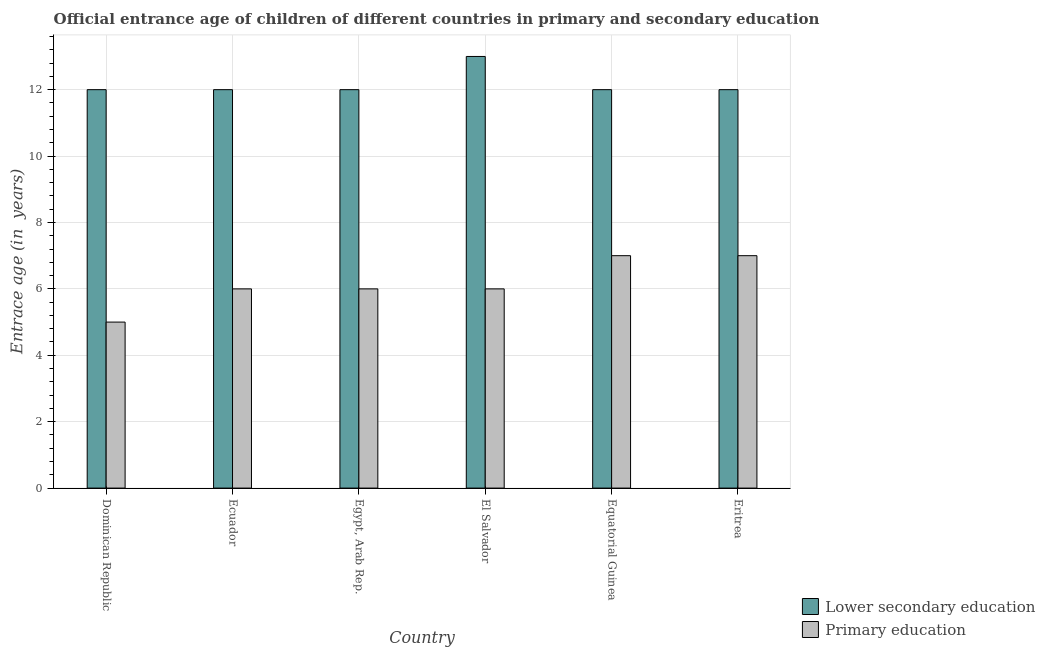Are the number of bars on each tick of the X-axis equal?
Your answer should be compact. Yes. How many bars are there on the 6th tick from the right?
Provide a short and direct response. 2. What is the label of the 4th group of bars from the left?
Offer a very short reply. El Salvador. What is the entrance age of chiildren in primary education in Egypt, Arab Rep.?
Your answer should be very brief. 6. Across all countries, what is the maximum entrance age of chiildren in primary education?
Provide a short and direct response. 7. Across all countries, what is the minimum entrance age of children in lower secondary education?
Your answer should be compact. 12. In which country was the entrance age of chiildren in primary education maximum?
Your answer should be very brief. Equatorial Guinea. In which country was the entrance age of chiildren in primary education minimum?
Make the answer very short. Dominican Republic. What is the total entrance age of children in lower secondary education in the graph?
Your response must be concise. 73. What is the difference between the entrance age of chiildren in primary education in Dominican Republic and the entrance age of children in lower secondary education in Eritrea?
Keep it short and to the point. -7. What is the average entrance age of chiildren in primary education per country?
Keep it short and to the point. 6.17. What is the difference between the entrance age of chiildren in primary education and entrance age of children in lower secondary education in El Salvador?
Keep it short and to the point. -7. What is the ratio of the entrance age of chiildren in primary education in Dominican Republic to that in El Salvador?
Give a very brief answer. 0.83. What is the difference between the highest and the lowest entrance age of children in lower secondary education?
Keep it short and to the point. 1. What does the 2nd bar from the left in Ecuador represents?
Make the answer very short. Primary education. What does the 2nd bar from the right in Dominican Republic represents?
Your answer should be very brief. Lower secondary education. How many bars are there?
Provide a short and direct response. 12. Are all the bars in the graph horizontal?
Offer a terse response. No. What is the difference between two consecutive major ticks on the Y-axis?
Your answer should be compact. 2. Are the values on the major ticks of Y-axis written in scientific E-notation?
Offer a very short reply. No. Where does the legend appear in the graph?
Make the answer very short. Bottom right. How many legend labels are there?
Provide a succinct answer. 2. How are the legend labels stacked?
Give a very brief answer. Vertical. What is the title of the graph?
Give a very brief answer. Official entrance age of children of different countries in primary and secondary education. Does "Gasoline" appear as one of the legend labels in the graph?
Make the answer very short. No. What is the label or title of the Y-axis?
Your answer should be compact. Entrace age (in  years). What is the Entrace age (in  years) in Primary education in Dominican Republic?
Offer a terse response. 5. What is the Entrace age (in  years) of Primary education in Ecuador?
Make the answer very short. 6. What is the Entrace age (in  years) in Lower secondary education in Egypt, Arab Rep.?
Keep it short and to the point. 12. What is the Entrace age (in  years) in Primary education in Egypt, Arab Rep.?
Offer a very short reply. 6. What is the Entrace age (in  years) in Lower secondary education in El Salvador?
Your answer should be very brief. 13. What is the Entrace age (in  years) of Primary education in El Salvador?
Make the answer very short. 6. Across all countries, what is the maximum Entrace age (in  years) in Lower secondary education?
Your answer should be very brief. 13. Across all countries, what is the maximum Entrace age (in  years) in Primary education?
Your answer should be compact. 7. Across all countries, what is the minimum Entrace age (in  years) of Primary education?
Keep it short and to the point. 5. What is the total Entrace age (in  years) in Lower secondary education in the graph?
Keep it short and to the point. 73. What is the difference between the Entrace age (in  years) of Lower secondary education in Dominican Republic and that in Ecuador?
Offer a very short reply. 0. What is the difference between the Entrace age (in  years) in Lower secondary education in Dominican Republic and that in Egypt, Arab Rep.?
Offer a terse response. 0. What is the difference between the Entrace age (in  years) in Lower secondary education in Dominican Republic and that in El Salvador?
Provide a succinct answer. -1. What is the difference between the Entrace age (in  years) in Lower secondary education in Dominican Republic and that in Eritrea?
Offer a very short reply. 0. What is the difference between the Entrace age (in  years) in Primary education in Dominican Republic and that in Eritrea?
Your response must be concise. -2. What is the difference between the Entrace age (in  years) of Lower secondary education in Ecuador and that in Egypt, Arab Rep.?
Offer a terse response. 0. What is the difference between the Entrace age (in  years) of Primary education in Ecuador and that in Egypt, Arab Rep.?
Make the answer very short. 0. What is the difference between the Entrace age (in  years) in Lower secondary education in Ecuador and that in El Salvador?
Provide a succinct answer. -1. What is the difference between the Entrace age (in  years) in Primary education in Ecuador and that in El Salvador?
Your answer should be very brief. 0. What is the difference between the Entrace age (in  years) in Lower secondary education in Ecuador and that in Equatorial Guinea?
Offer a terse response. 0. What is the difference between the Entrace age (in  years) in Primary education in Ecuador and that in Equatorial Guinea?
Your response must be concise. -1. What is the difference between the Entrace age (in  years) of Primary education in Egypt, Arab Rep. and that in El Salvador?
Give a very brief answer. 0. What is the difference between the Entrace age (in  years) in Lower secondary education in Egypt, Arab Rep. and that in Equatorial Guinea?
Your answer should be very brief. 0. What is the difference between the Entrace age (in  years) in Primary education in Egypt, Arab Rep. and that in Equatorial Guinea?
Make the answer very short. -1. What is the difference between the Entrace age (in  years) in Primary education in Egypt, Arab Rep. and that in Eritrea?
Your answer should be compact. -1. What is the difference between the Entrace age (in  years) of Lower secondary education in El Salvador and that in Eritrea?
Keep it short and to the point. 1. What is the difference between the Entrace age (in  years) of Primary education in El Salvador and that in Eritrea?
Make the answer very short. -1. What is the difference between the Entrace age (in  years) of Lower secondary education in Dominican Republic and the Entrace age (in  years) of Primary education in Egypt, Arab Rep.?
Provide a short and direct response. 6. What is the difference between the Entrace age (in  years) in Lower secondary education in Dominican Republic and the Entrace age (in  years) in Primary education in El Salvador?
Your answer should be very brief. 6. What is the difference between the Entrace age (in  years) of Lower secondary education in Dominican Republic and the Entrace age (in  years) of Primary education in Equatorial Guinea?
Ensure brevity in your answer.  5. What is the difference between the Entrace age (in  years) of Lower secondary education in Ecuador and the Entrace age (in  years) of Primary education in Egypt, Arab Rep.?
Your response must be concise. 6. What is the difference between the Entrace age (in  years) in Lower secondary education in Ecuador and the Entrace age (in  years) in Primary education in Equatorial Guinea?
Your response must be concise. 5. What is the difference between the Entrace age (in  years) in Lower secondary education in Ecuador and the Entrace age (in  years) in Primary education in Eritrea?
Offer a terse response. 5. What is the difference between the Entrace age (in  years) of Lower secondary education in Egypt, Arab Rep. and the Entrace age (in  years) of Primary education in El Salvador?
Ensure brevity in your answer.  6. What is the difference between the Entrace age (in  years) in Lower secondary education in Egypt, Arab Rep. and the Entrace age (in  years) in Primary education in Equatorial Guinea?
Offer a terse response. 5. What is the difference between the Entrace age (in  years) in Lower secondary education in Egypt, Arab Rep. and the Entrace age (in  years) in Primary education in Eritrea?
Ensure brevity in your answer.  5. What is the difference between the Entrace age (in  years) in Lower secondary education in El Salvador and the Entrace age (in  years) in Primary education in Equatorial Guinea?
Your answer should be very brief. 6. What is the average Entrace age (in  years) in Lower secondary education per country?
Provide a succinct answer. 12.17. What is the average Entrace age (in  years) of Primary education per country?
Your answer should be compact. 6.17. What is the difference between the Entrace age (in  years) in Lower secondary education and Entrace age (in  years) in Primary education in Eritrea?
Give a very brief answer. 5. What is the ratio of the Entrace age (in  years) in Lower secondary education in Dominican Republic to that in Ecuador?
Your response must be concise. 1. What is the ratio of the Entrace age (in  years) in Primary education in Dominican Republic to that in Ecuador?
Your answer should be very brief. 0.83. What is the ratio of the Entrace age (in  years) of Primary education in Dominican Republic to that in Egypt, Arab Rep.?
Provide a succinct answer. 0.83. What is the ratio of the Entrace age (in  years) of Lower secondary education in Dominican Republic to that in El Salvador?
Offer a very short reply. 0.92. What is the ratio of the Entrace age (in  years) of Primary education in Dominican Republic to that in El Salvador?
Provide a short and direct response. 0.83. What is the ratio of the Entrace age (in  years) of Lower secondary education in Dominican Republic to that in Equatorial Guinea?
Ensure brevity in your answer.  1. What is the ratio of the Entrace age (in  years) in Primary education in Dominican Republic to that in Equatorial Guinea?
Offer a very short reply. 0.71. What is the ratio of the Entrace age (in  years) of Lower secondary education in Ecuador to that in Egypt, Arab Rep.?
Your answer should be compact. 1. What is the ratio of the Entrace age (in  years) in Primary education in Ecuador to that in Egypt, Arab Rep.?
Keep it short and to the point. 1. What is the ratio of the Entrace age (in  years) of Lower secondary education in Ecuador to that in El Salvador?
Ensure brevity in your answer.  0.92. What is the ratio of the Entrace age (in  years) in Primary education in Ecuador to that in Equatorial Guinea?
Your response must be concise. 0.86. What is the ratio of the Entrace age (in  years) of Lower secondary education in Ecuador to that in Eritrea?
Keep it short and to the point. 1. What is the ratio of the Entrace age (in  years) of Primary education in Egypt, Arab Rep. to that in Equatorial Guinea?
Your answer should be compact. 0.86. What is the ratio of the Entrace age (in  years) of Lower secondary education in Egypt, Arab Rep. to that in Eritrea?
Offer a very short reply. 1. What is the ratio of the Entrace age (in  years) in Lower secondary education in El Salvador to that in Equatorial Guinea?
Keep it short and to the point. 1.08. What is the ratio of the Entrace age (in  years) of Primary education in El Salvador to that in Equatorial Guinea?
Ensure brevity in your answer.  0.86. What is the ratio of the Entrace age (in  years) in Lower secondary education in El Salvador to that in Eritrea?
Give a very brief answer. 1.08. What is the ratio of the Entrace age (in  years) of Primary education in El Salvador to that in Eritrea?
Make the answer very short. 0.86. What is the ratio of the Entrace age (in  years) of Lower secondary education in Equatorial Guinea to that in Eritrea?
Give a very brief answer. 1. What is the difference between the highest and the second highest Entrace age (in  years) of Lower secondary education?
Give a very brief answer. 1. What is the difference between the highest and the lowest Entrace age (in  years) of Primary education?
Your answer should be compact. 2. 